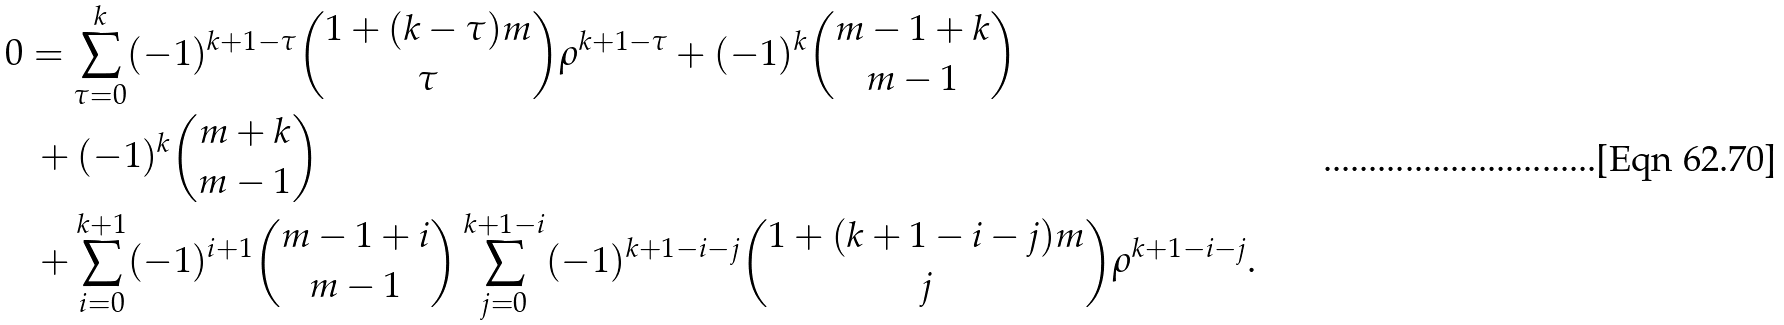<formula> <loc_0><loc_0><loc_500><loc_500>0 & = \sum _ { \tau = 0 } ^ { k } ( - 1 ) ^ { k + 1 - \tau } \binom { 1 + ( k - \tau ) m } { \tau } \rho ^ { k + 1 - \tau } + ( - 1 ) ^ { k } \binom { m - 1 + k } { m - 1 } \\ & \ + ( - 1 ) ^ { k } \binom { m + k } { m - 1 } \\ & \ + \sum _ { i = 0 } ^ { k + 1 } ( - 1 ) ^ { i + 1 } \binom { m - 1 + i } { m - 1 } \sum _ { j = 0 } ^ { k + 1 - i } ( - 1 ) ^ { k + 1 - i - j } \binom { 1 + ( k + 1 - i - j ) m } j \rho ^ { k + 1 - i - j } .</formula> 